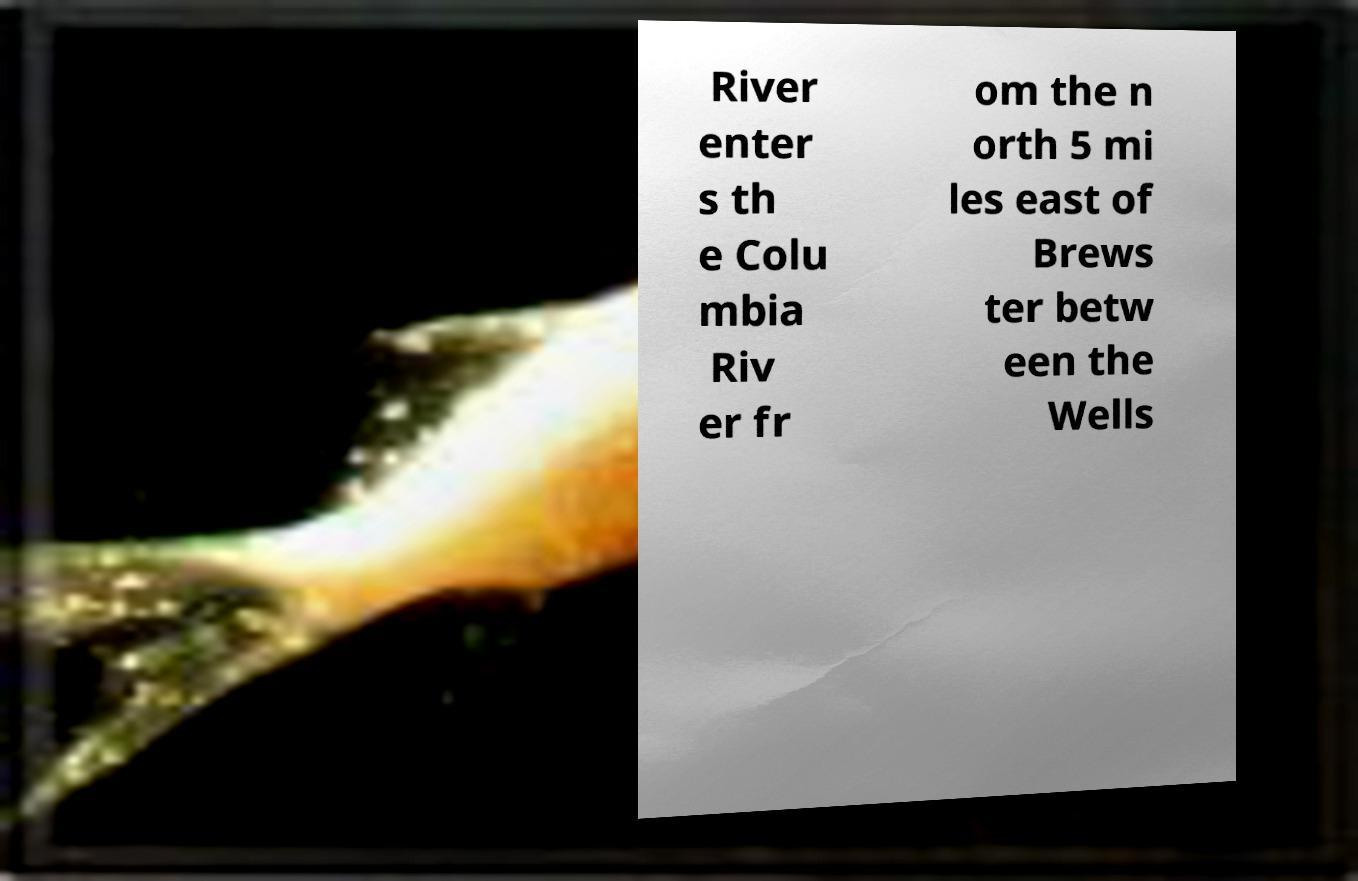Can you read and provide the text displayed in the image?This photo seems to have some interesting text. Can you extract and type it out for me? River enter s th e Colu mbia Riv er fr om the n orth 5 mi les east of Brews ter betw een the Wells 